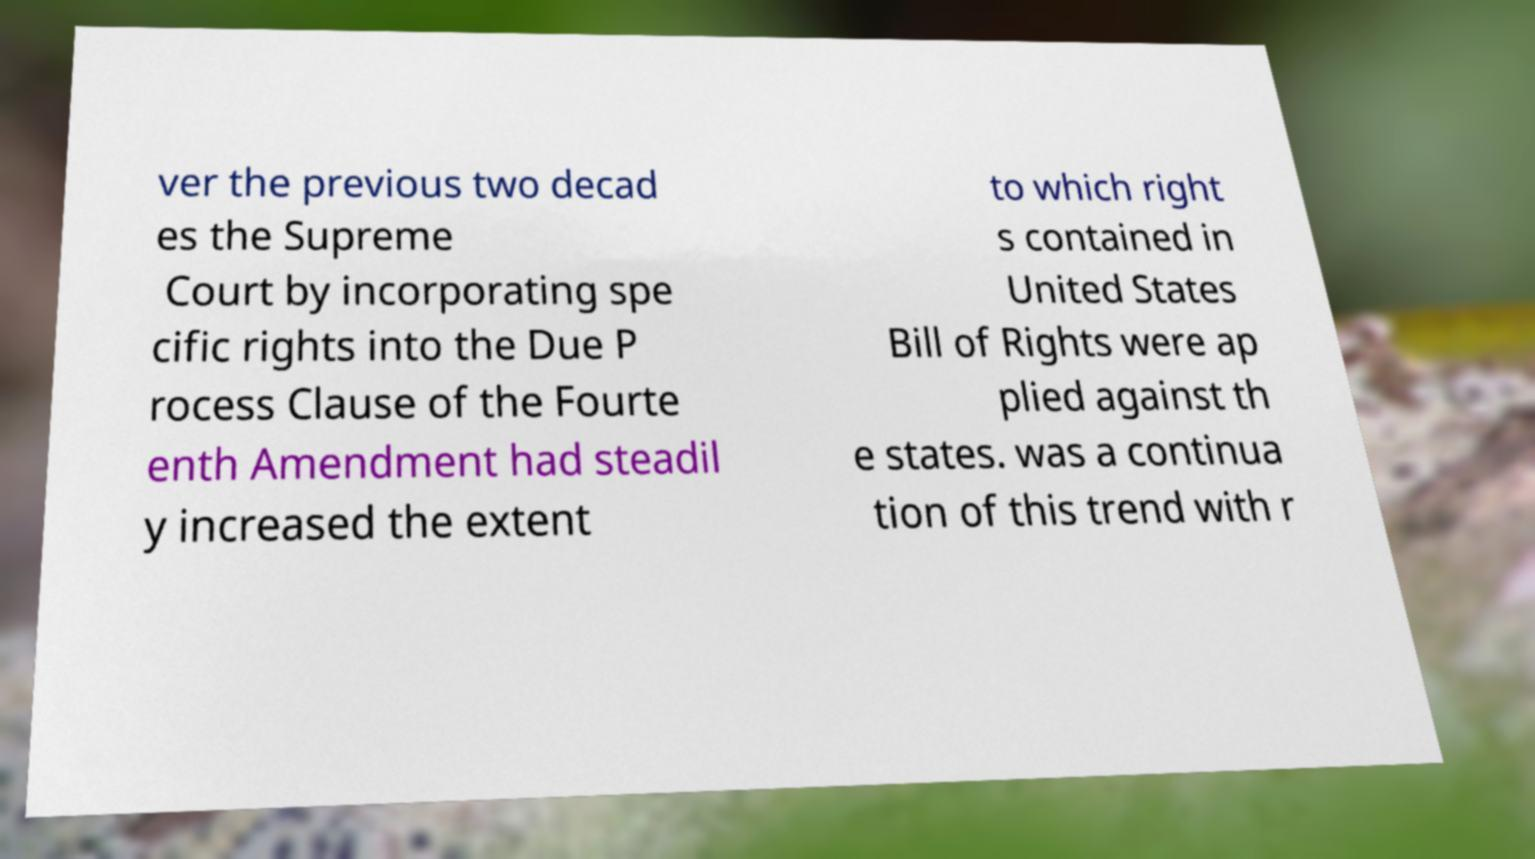What messages or text are displayed in this image? I need them in a readable, typed format. ver the previous two decad es the Supreme Court by incorporating spe cific rights into the Due P rocess Clause of the Fourte enth Amendment had steadil y increased the extent to which right s contained in United States Bill of Rights were ap plied against th e states. was a continua tion of this trend with r 